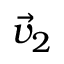Convert formula to latex. <formula><loc_0><loc_0><loc_500><loc_500>\vec { v } _ { 2 }</formula> 